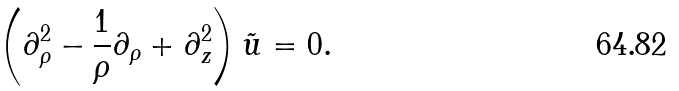<formula> <loc_0><loc_0><loc_500><loc_500>\left ( \partial _ { \rho } ^ { 2 } - \frac { 1 } { \rho } \partial _ { \rho } + \partial _ { z } ^ { 2 } \right ) \tilde { u } = 0 .</formula> 